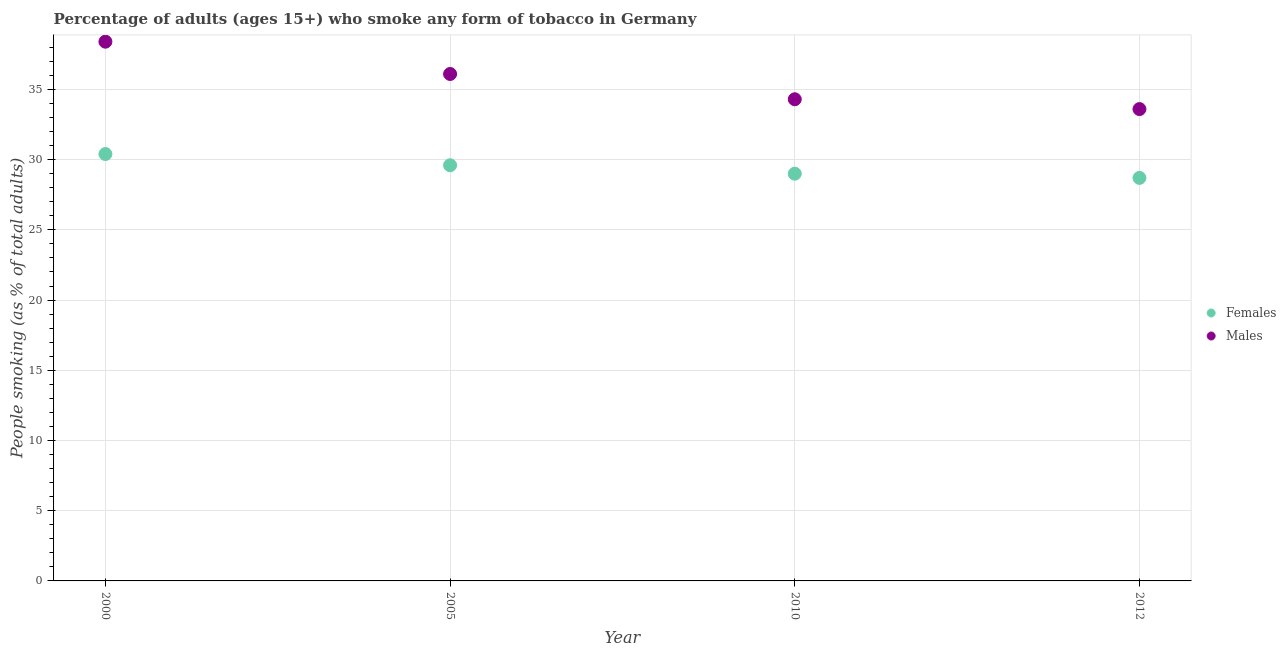How many different coloured dotlines are there?
Your answer should be compact. 2. Is the number of dotlines equal to the number of legend labels?
Your response must be concise. Yes. What is the percentage of females who smoke in 2012?
Offer a very short reply. 28.7. Across all years, what is the maximum percentage of males who smoke?
Ensure brevity in your answer.  38.4. Across all years, what is the minimum percentage of males who smoke?
Give a very brief answer. 33.6. In which year was the percentage of males who smoke maximum?
Your answer should be compact. 2000. In which year was the percentage of males who smoke minimum?
Provide a succinct answer. 2012. What is the total percentage of males who smoke in the graph?
Provide a short and direct response. 142.4. What is the difference between the percentage of females who smoke in 2005 and that in 2010?
Your answer should be very brief. 0.6. What is the difference between the percentage of females who smoke in 2000 and the percentage of males who smoke in 2005?
Provide a short and direct response. -5.7. What is the average percentage of males who smoke per year?
Your response must be concise. 35.6. In how many years, is the percentage of females who smoke greater than 7 %?
Provide a succinct answer. 4. What is the ratio of the percentage of females who smoke in 2000 to that in 2010?
Ensure brevity in your answer.  1.05. Is the percentage of males who smoke in 2000 less than that in 2010?
Make the answer very short. No. What is the difference between the highest and the second highest percentage of females who smoke?
Ensure brevity in your answer.  0.8. What is the difference between the highest and the lowest percentage of females who smoke?
Offer a terse response. 1.7. In how many years, is the percentage of females who smoke greater than the average percentage of females who smoke taken over all years?
Provide a succinct answer. 2. How many dotlines are there?
Offer a terse response. 2. What is the difference between two consecutive major ticks on the Y-axis?
Ensure brevity in your answer.  5. Does the graph contain any zero values?
Your answer should be very brief. No. Where does the legend appear in the graph?
Keep it short and to the point. Center right. What is the title of the graph?
Provide a short and direct response. Percentage of adults (ages 15+) who smoke any form of tobacco in Germany. What is the label or title of the Y-axis?
Provide a succinct answer. People smoking (as % of total adults). What is the People smoking (as % of total adults) in Females in 2000?
Make the answer very short. 30.4. What is the People smoking (as % of total adults) in Males in 2000?
Provide a short and direct response. 38.4. What is the People smoking (as % of total adults) in Females in 2005?
Offer a very short reply. 29.6. What is the People smoking (as % of total adults) in Males in 2005?
Provide a succinct answer. 36.1. What is the People smoking (as % of total adults) in Females in 2010?
Offer a very short reply. 29. What is the People smoking (as % of total adults) in Males in 2010?
Offer a terse response. 34.3. What is the People smoking (as % of total adults) of Females in 2012?
Ensure brevity in your answer.  28.7. What is the People smoking (as % of total adults) of Males in 2012?
Your response must be concise. 33.6. Across all years, what is the maximum People smoking (as % of total adults) of Females?
Provide a short and direct response. 30.4. Across all years, what is the maximum People smoking (as % of total adults) of Males?
Keep it short and to the point. 38.4. Across all years, what is the minimum People smoking (as % of total adults) in Females?
Your answer should be very brief. 28.7. Across all years, what is the minimum People smoking (as % of total adults) in Males?
Ensure brevity in your answer.  33.6. What is the total People smoking (as % of total adults) of Females in the graph?
Your response must be concise. 117.7. What is the total People smoking (as % of total adults) in Males in the graph?
Ensure brevity in your answer.  142.4. What is the difference between the People smoking (as % of total adults) of Females in 2000 and that in 2005?
Give a very brief answer. 0.8. What is the difference between the People smoking (as % of total adults) in Females in 2000 and that in 2010?
Keep it short and to the point. 1.4. What is the difference between the People smoking (as % of total adults) in Males in 2000 and that in 2010?
Give a very brief answer. 4.1. What is the difference between the People smoking (as % of total adults) of Females in 2000 and that in 2012?
Your answer should be compact. 1.7. What is the difference between the People smoking (as % of total adults) in Males in 2000 and that in 2012?
Your response must be concise. 4.8. What is the difference between the People smoking (as % of total adults) of Males in 2005 and that in 2010?
Provide a short and direct response. 1.8. What is the difference between the People smoking (as % of total adults) in Males in 2005 and that in 2012?
Provide a short and direct response. 2.5. What is the difference between the People smoking (as % of total adults) in Females in 2010 and that in 2012?
Ensure brevity in your answer.  0.3. What is the difference between the People smoking (as % of total adults) of Males in 2010 and that in 2012?
Provide a succinct answer. 0.7. What is the difference between the People smoking (as % of total adults) in Females in 2005 and the People smoking (as % of total adults) in Males in 2012?
Keep it short and to the point. -4. What is the difference between the People smoking (as % of total adults) in Females in 2010 and the People smoking (as % of total adults) in Males in 2012?
Your answer should be very brief. -4.6. What is the average People smoking (as % of total adults) of Females per year?
Offer a terse response. 29.43. What is the average People smoking (as % of total adults) in Males per year?
Your answer should be very brief. 35.6. In the year 2010, what is the difference between the People smoking (as % of total adults) in Females and People smoking (as % of total adults) in Males?
Provide a short and direct response. -5.3. What is the ratio of the People smoking (as % of total adults) of Females in 2000 to that in 2005?
Give a very brief answer. 1.03. What is the ratio of the People smoking (as % of total adults) in Males in 2000 to that in 2005?
Offer a terse response. 1.06. What is the ratio of the People smoking (as % of total adults) in Females in 2000 to that in 2010?
Offer a very short reply. 1.05. What is the ratio of the People smoking (as % of total adults) of Males in 2000 to that in 2010?
Provide a short and direct response. 1.12. What is the ratio of the People smoking (as % of total adults) in Females in 2000 to that in 2012?
Provide a succinct answer. 1.06. What is the ratio of the People smoking (as % of total adults) in Females in 2005 to that in 2010?
Your answer should be very brief. 1.02. What is the ratio of the People smoking (as % of total adults) of Males in 2005 to that in 2010?
Your response must be concise. 1.05. What is the ratio of the People smoking (as % of total adults) in Females in 2005 to that in 2012?
Make the answer very short. 1.03. What is the ratio of the People smoking (as % of total adults) of Males in 2005 to that in 2012?
Your answer should be compact. 1.07. What is the ratio of the People smoking (as % of total adults) in Females in 2010 to that in 2012?
Give a very brief answer. 1.01. What is the ratio of the People smoking (as % of total adults) in Males in 2010 to that in 2012?
Provide a succinct answer. 1.02. What is the difference between the highest and the lowest People smoking (as % of total adults) of Females?
Offer a very short reply. 1.7. What is the difference between the highest and the lowest People smoking (as % of total adults) of Males?
Give a very brief answer. 4.8. 